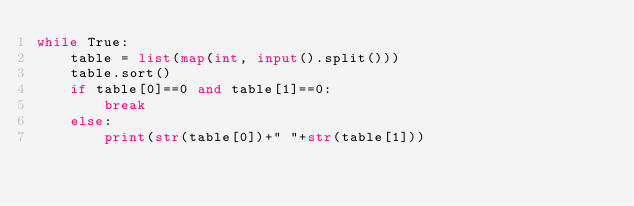Convert code to text. <code><loc_0><loc_0><loc_500><loc_500><_Python_>while True:
    table = list(map(int, input().split()))
    table.sort()
    if table[0]==0 and table[1]==0:
        break
    else:
        print(str(table[0])+" "+str(table[1]))
</code> 